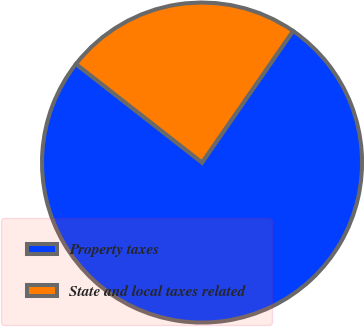<chart> <loc_0><loc_0><loc_500><loc_500><pie_chart><fcel>Property taxes<fcel>State and local taxes related<nl><fcel>75.93%<fcel>24.07%<nl></chart> 